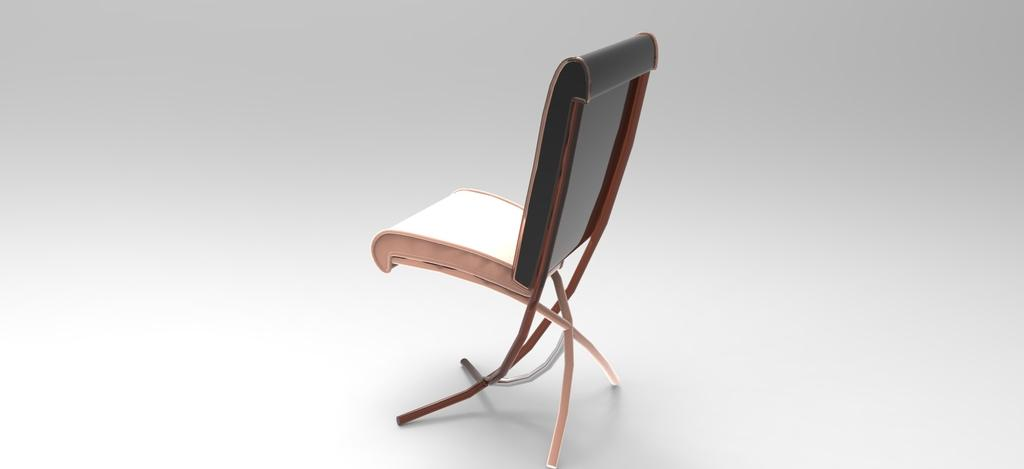What type of furniture is present in the image? There is a chair in the image. What type of knowledge can be gained from the chair in the image? The chair in the image does not convey any knowledge; it is simply a piece of furniture. 